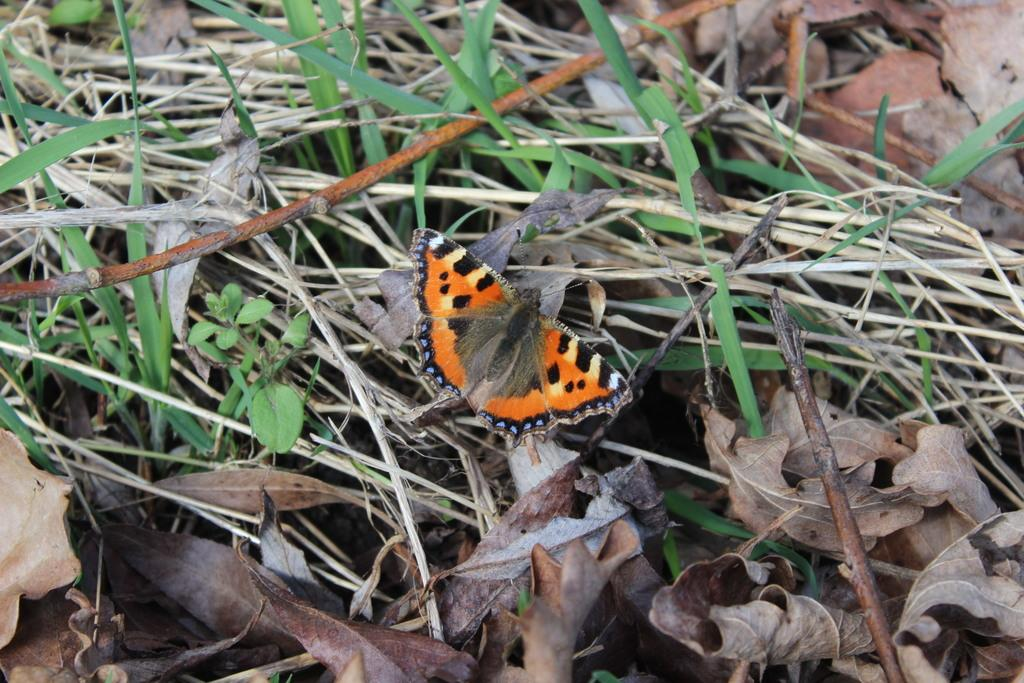What type of animal can be seen in the image? There is a butterfly in the image. What type of plant material is present in the image? There are leaves and grass in the image. Can you tell me how many jellyfish are swimming in the grass in the image? There are no jellyfish present in the image; it features a butterfly, leaves, and grass. What is the temperature of the environment in the image? The provided facts do not mention the temperature or any indication of the environment's warmth or coolness. 